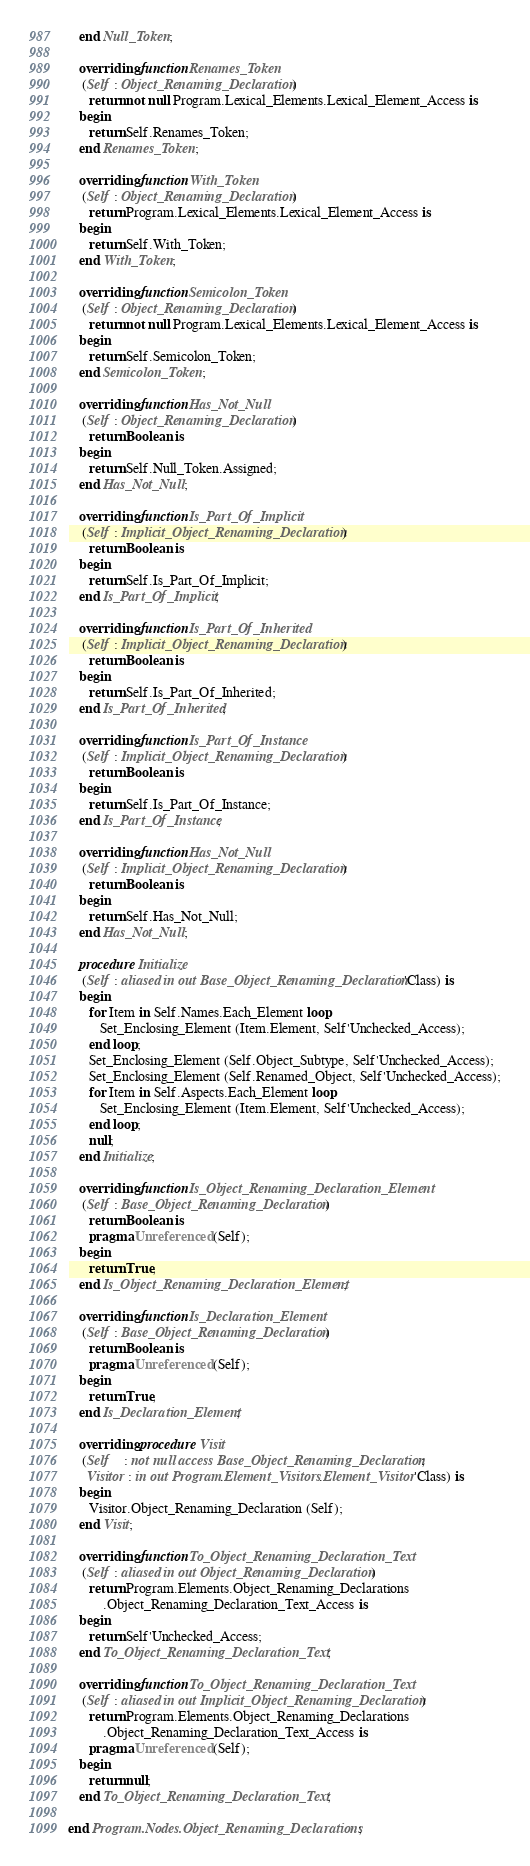Convert code to text. <code><loc_0><loc_0><loc_500><loc_500><_Ada_>   end Null_Token;

   overriding function Renames_Token
    (Self : Object_Renaming_Declaration)
      return not null Program.Lexical_Elements.Lexical_Element_Access is
   begin
      return Self.Renames_Token;
   end Renames_Token;

   overriding function With_Token
    (Self : Object_Renaming_Declaration)
      return Program.Lexical_Elements.Lexical_Element_Access is
   begin
      return Self.With_Token;
   end With_Token;

   overriding function Semicolon_Token
    (Self : Object_Renaming_Declaration)
      return not null Program.Lexical_Elements.Lexical_Element_Access is
   begin
      return Self.Semicolon_Token;
   end Semicolon_Token;

   overriding function Has_Not_Null
    (Self : Object_Renaming_Declaration)
      return Boolean is
   begin
      return Self.Null_Token.Assigned;
   end Has_Not_Null;

   overriding function Is_Part_Of_Implicit
    (Self : Implicit_Object_Renaming_Declaration)
      return Boolean is
   begin
      return Self.Is_Part_Of_Implicit;
   end Is_Part_Of_Implicit;

   overriding function Is_Part_Of_Inherited
    (Self : Implicit_Object_Renaming_Declaration)
      return Boolean is
   begin
      return Self.Is_Part_Of_Inherited;
   end Is_Part_Of_Inherited;

   overriding function Is_Part_Of_Instance
    (Self : Implicit_Object_Renaming_Declaration)
      return Boolean is
   begin
      return Self.Is_Part_Of_Instance;
   end Is_Part_Of_Instance;

   overriding function Has_Not_Null
    (Self : Implicit_Object_Renaming_Declaration)
      return Boolean is
   begin
      return Self.Has_Not_Null;
   end Has_Not_Null;

   procedure Initialize
    (Self : aliased in out Base_Object_Renaming_Declaration'Class) is
   begin
      for Item in Self.Names.Each_Element loop
         Set_Enclosing_Element (Item.Element, Self'Unchecked_Access);
      end loop;
      Set_Enclosing_Element (Self.Object_Subtype, Self'Unchecked_Access);
      Set_Enclosing_Element (Self.Renamed_Object, Self'Unchecked_Access);
      for Item in Self.Aspects.Each_Element loop
         Set_Enclosing_Element (Item.Element, Self'Unchecked_Access);
      end loop;
      null;
   end Initialize;

   overriding function Is_Object_Renaming_Declaration_Element
    (Self : Base_Object_Renaming_Declaration)
      return Boolean is
      pragma Unreferenced (Self);
   begin
      return True;
   end Is_Object_Renaming_Declaration_Element;

   overriding function Is_Declaration_Element
    (Self : Base_Object_Renaming_Declaration)
      return Boolean is
      pragma Unreferenced (Self);
   begin
      return True;
   end Is_Declaration_Element;

   overriding procedure Visit
    (Self    : not null access Base_Object_Renaming_Declaration;
     Visitor : in out Program.Element_Visitors.Element_Visitor'Class) is
   begin
      Visitor.Object_Renaming_Declaration (Self);
   end Visit;

   overriding function To_Object_Renaming_Declaration_Text
    (Self : aliased in out Object_Renaming_Declaration)
      return Program.Elements.Object_Renaming_Declarations
          .Object_Renaming_Declaration_Text_Access is
   begin
      return Self'Unchecked_Access;
   end To_Object_Renaming_Declaration_Text;

   overriding function To_Object_Renaming_Declaration_Text
    (Self : aliased in out Implicit_Object_Renaming_Declaration)
      return Program.Elements.Object_Renaming_Declarations
          .Object_Renaming_Declaration_Text_Access is
      pragma Unreferenced (Self);
   begin
      return null;
   end To_Object_Renaming_Declaration_Text;

end Program.Nodes.Object_Renaming_Declarations;
</code> 